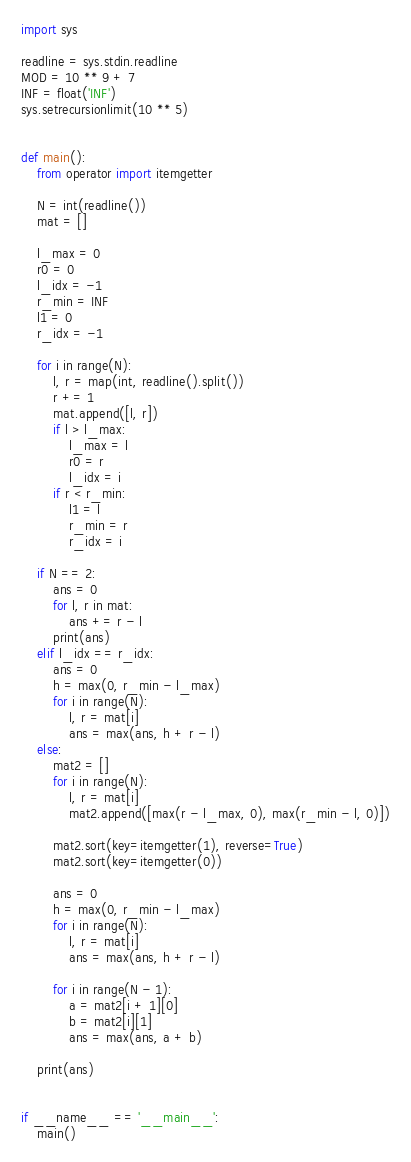<code> <loc_0><loc_0><loc_500><loc_500><_Python_>import sys

readline = sys.stdin.readline
MOD = 10 ** 9 + 7
INF = float('INF')
sys.setrecursionlimit(10 ** 5)


def main():
    from operator import itemgetter

    N = int(readline())
    mat = []

    l_max = 0
    r0 = 0
    l_idx = -1
    r_min = INF
    l1 = 0
    r_idx = -1

    for i in range(N):
        l, r = map(int, readline().split())
        r += 1
        mat.append([l, r])
        if l > l_max:
            l_max = l
            r0 = r
            l_idx = i
        if r < r_min:
            l1 = l
            r_min = r
            r_idx = i

    if N == 2:
        ans = 0
        for l, r in mat:
            ans += r - l
        print(ans)
    elif l_idx == r_idx:
        ans = 0
        h = max(0, r_min - l_max)
        for i in range(N):
            l, r = mat[i]
            ans = max(ans, h + r - l)
    else:
        mat2 = []
        for i in range(N):
            l, r = mat[i]
            mat2.append([max(r - l_max, 0), max(r_min - l, 0)])

        mat2.sort(key=itemgetter(1), reverse=True)
        mat2.sort(key=itemgetter(0))

        ans = 0
        h = max(0, r_min - l_max)
        for i in range(N):
            l, r = mat[i]
            ans = max(ans, h + r - l)

        for i in range(N - 1):
            a = mat2[i + 1][0]
            b = mat2[i][1]
            ans = max(ans, a + b)

    print(ans)


if __name__ == '__main__':
    main()
</code> 